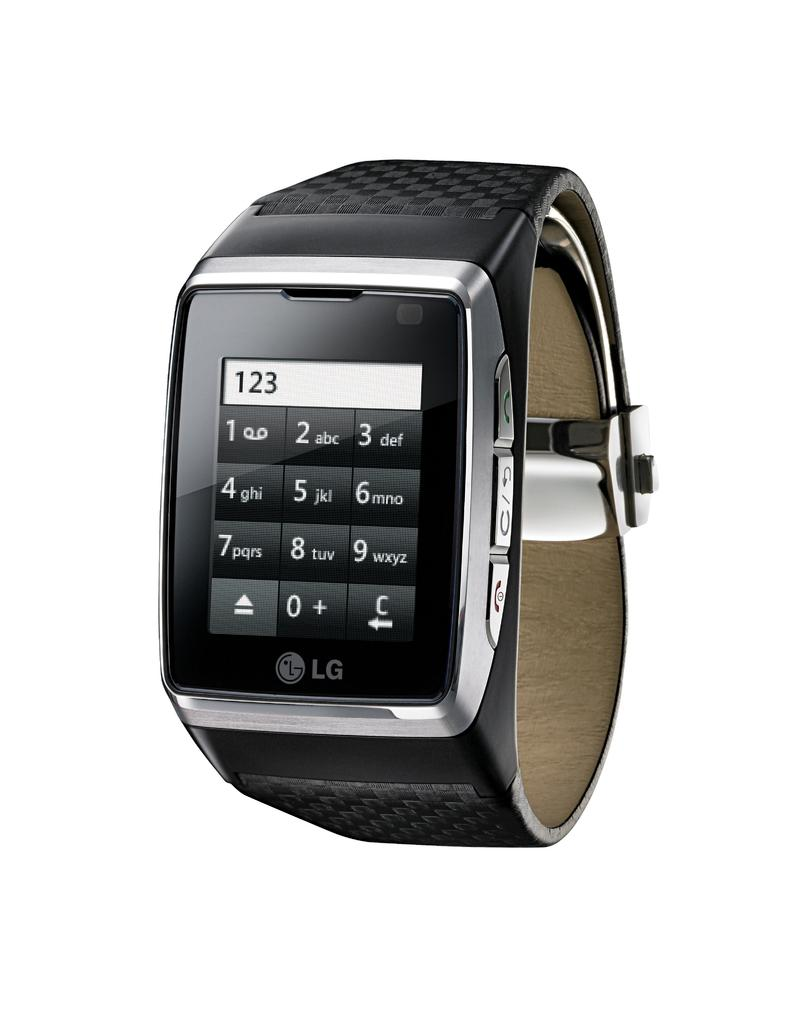<image>
Offer a succinct explanation of the picture presented. A black smartwatch says LG and is displaying a calculator. 